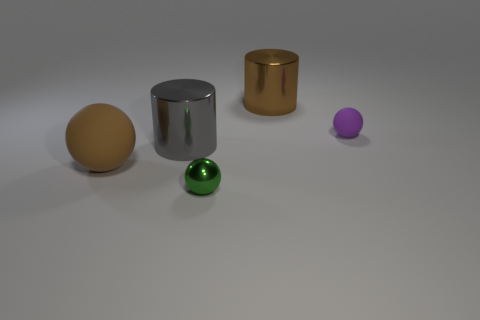Subtract all green spheres. How many spheres are left? 2 Add 5 red matte objects. How many objects exist? 10 Subtract all balls. How many objects are left? 2 Subtract all blue balls. Subtract all gray cubes. How many balls are left? 3 Subtract all brown metal cylinders. Subtract all large gray cylinders. How many objects are left? 3 Add 1 large rubber spheres. How many large rubber spheres are left? 2 Add 5 green cylinders. How many green cylinders exist? 5 Subtract 0 blue cubes. How many objects are left? 5 